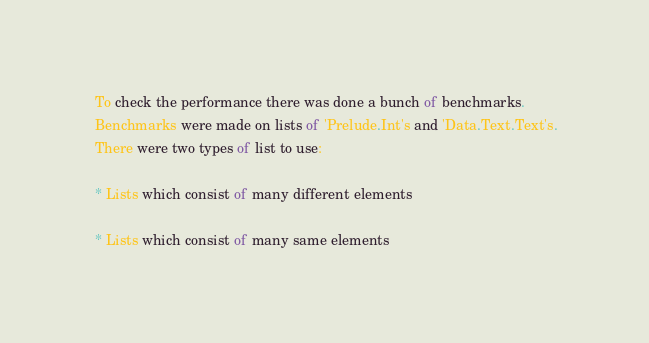<code> <loc_0><loc_0><loc_500><loc_500><_Haskell_> To check the performance there was done a bunch of benchmarks.
 Benchmarks were made on lists of 'Prelude.Int's and 'Data.Text.Text's.
 There were two types of list to use:

 * Lists which consist of many different elements

 * Lists which consist of many same elements

</code> 